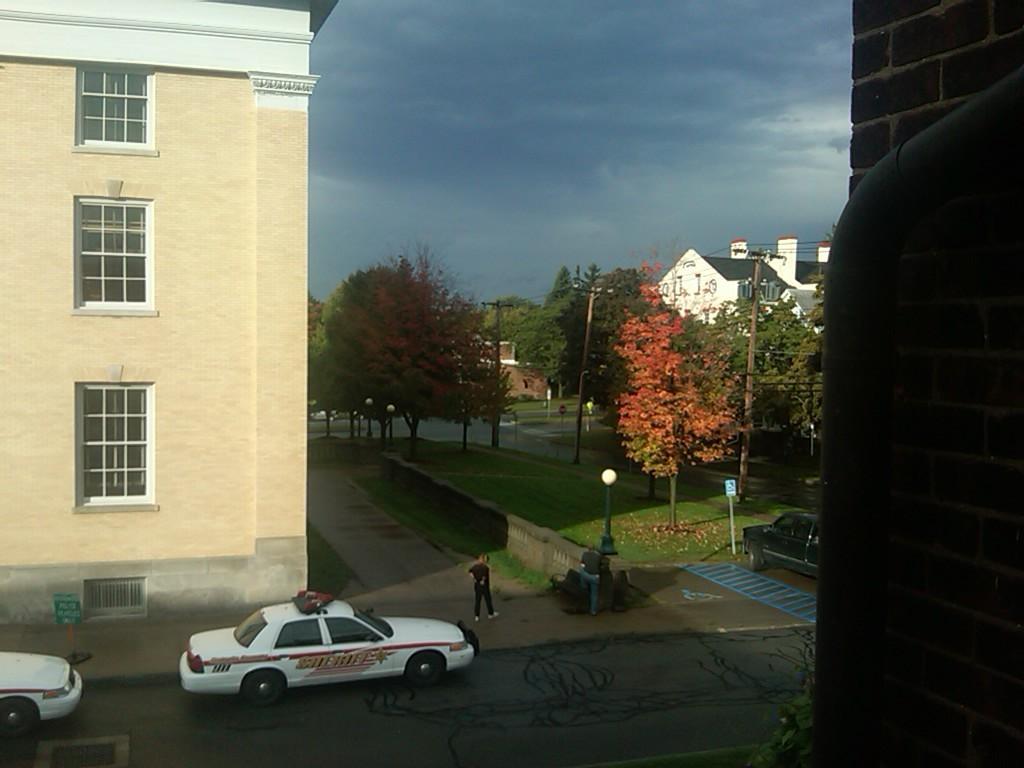Could you give a brief overview of what you see in this image? In this image there are a few cars passing on the road, and there is a person standing on the road, on either side of the road there are buildings in between there are trees and lampposts and grass on the surface. 